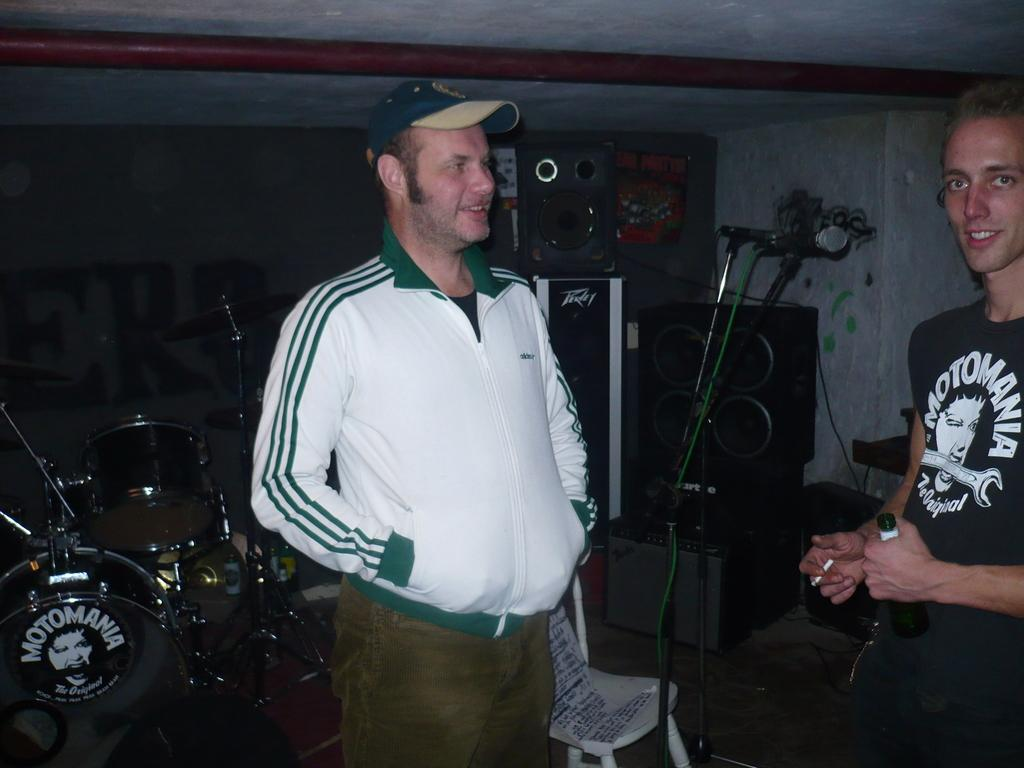How many people are in the image? There are two men standing in the image. What is one of the men holding? One of the men is holding a wine bottle. What musical equipment can be seen in the background? There is a drum set, speakers, and a microphone with a stand in the background. What time of day is represented by the hour on the clock in the image? There is no clock present in the image, so it is not possible to determine the time of day. 